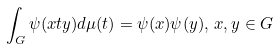<formula> <loc_0><loc_0><loc_500><loc_500>\int _ { G } \psi ( x t y ) d \mu ( t ) = \psi ( x ) \psi ( y ) , \, x , y \in G</formula> 